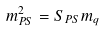<formula> <loc_0><loc_0><loc_500><loc_500>m _ { P S } ^ { 2 } = S _ { P S } m _ { q }</formula> 